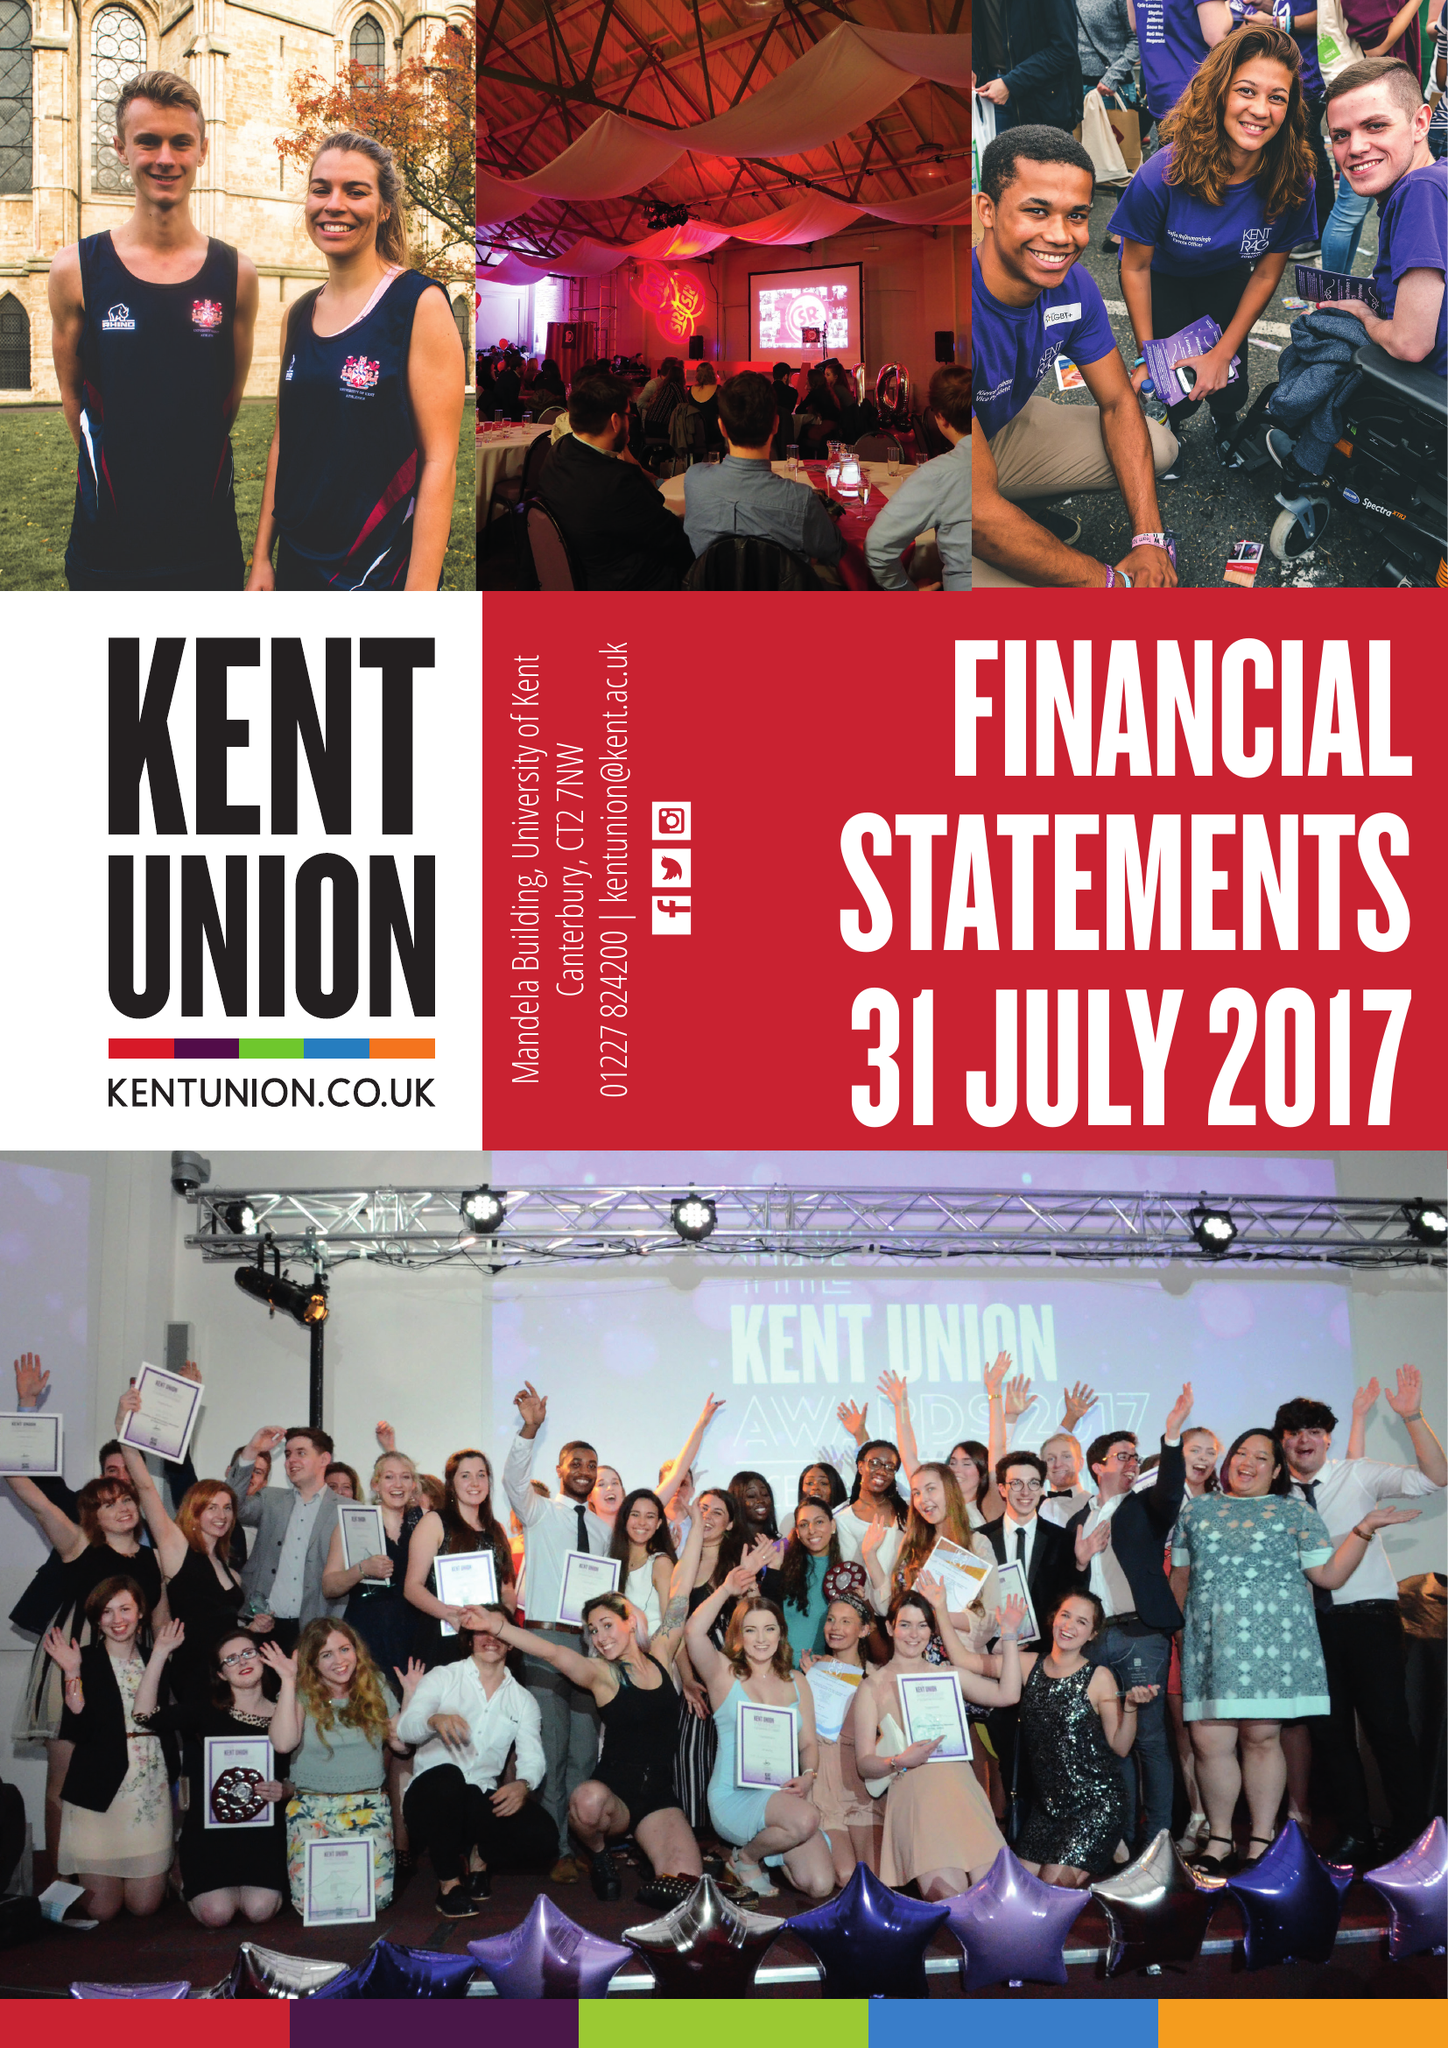What is the value for the income_annually_in_british_pounds?
Answer the question using a single word or phrase. 11999586.00 